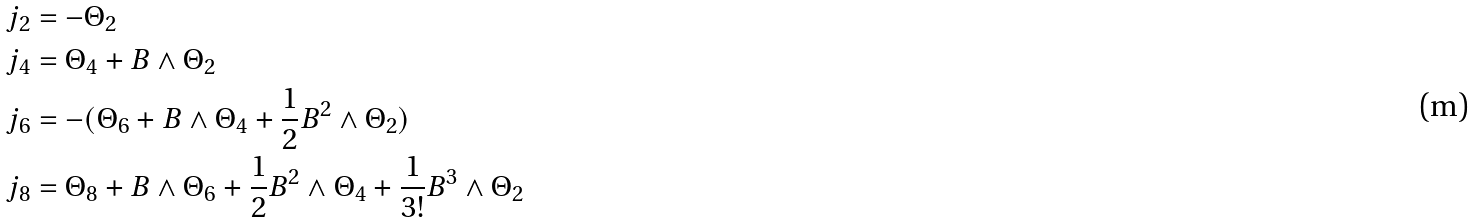Convert formula to latex. <formula><loc_0><loc_0><loc_500><loc_500>j _ { 2 } & = - \Theta _ { 2 } \\ j _ { 4 } & = \Theta _ { 4 } + B \wedge \Theta _ { 2 } \\ j _ { 6 } & = - ( \Theta _ { 6 } + B \wedge \Theta _ { 4 } + \frac { 1 } { 2 } B ^ { 2 } \wedge \Theta _ { 2 } ) \\ j _ { 8 } & = \Theta _ { 8 } + B \wedge \Theta _ { 6 } + \frac { 1 } { 2 } B ^ { 2 } \wedge \Theta _ { 4 } + \frac { 1 } { 3 ! } B ^ { 3 } \wedge \Theta _ { 2 }</formula> 